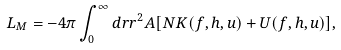Convert formula to latex. <formula><loc_0><loc_0><loc_500><loc_500>L _ { M } = - 4 \pi \int _ { 0 } ^ { \infty } d r r ^ { 2 } A [ N K ( f , h , u ) + U ( f , h , u ) ] ,</formula> 